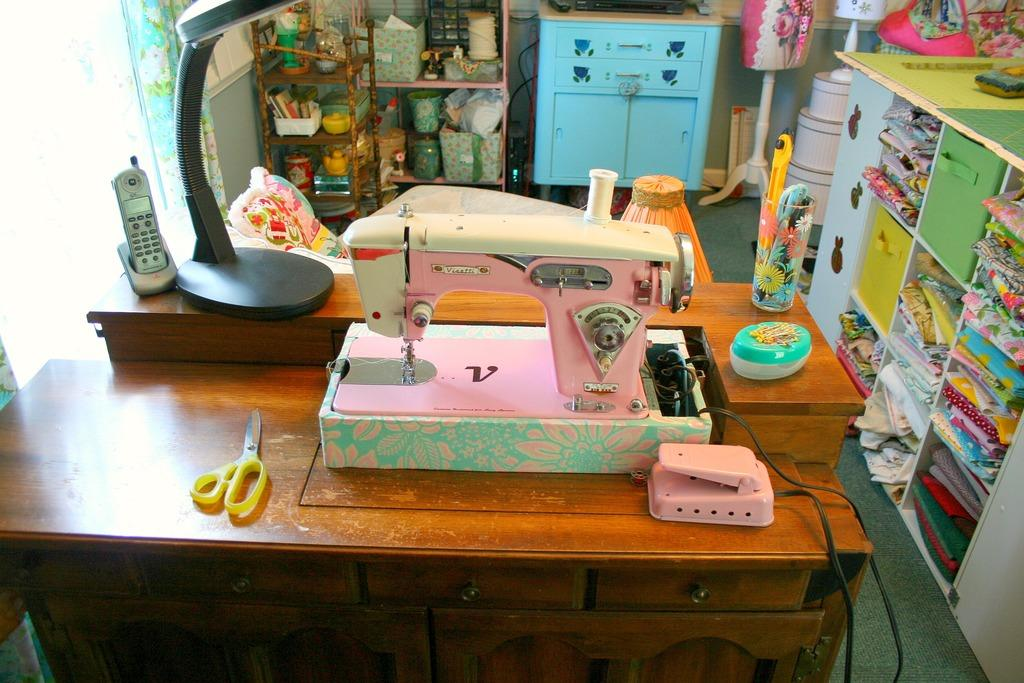What type of machine is visible in the image? There is a teller-machine in the image. What object is on the table in the image? There is a scissor on the table in the image. What type of clothing is stored in the cuboid in the image? There are dresses in a cuboid in the image. Where is the telephone located in the image? The telephone is on the left side of the image. What type of plastic material is being pulled by the horse in the image? There is no horse or plastic material present in the image. How does the horse interact with the scissor in the image? There is no horse present in the image, so it cannot interact with the scissor. 